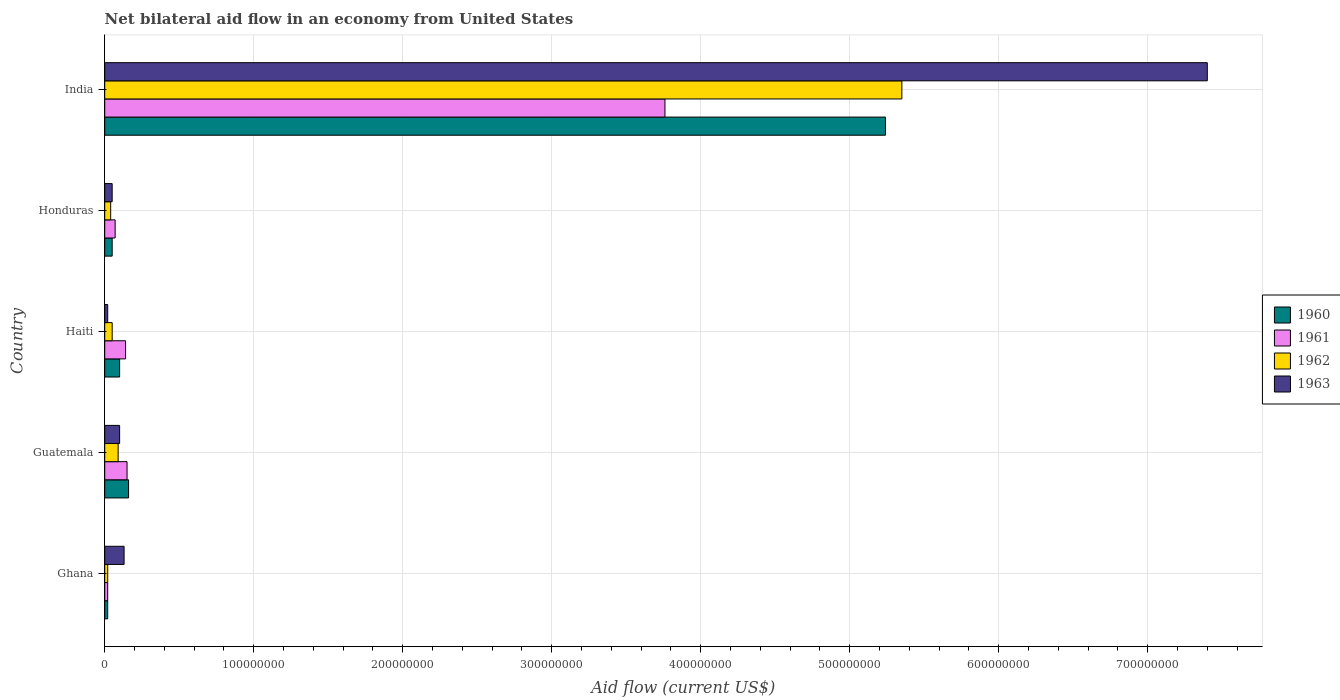How many different coloured bars are there?
Provide a short and direct response. 4. How many groups of bars are there?
Your answer should be compact. 5. How many bars are there on the 4th tick from the bottom?
Ensure brevity in your answer.  4. What is the label of the 4th group of bars from the top?
Ensure brevity in your answer.  Guatemala. What is the net bilateral aid flow in 1962 in Guatemala?
Keep it short and to the point. 9.00e+06. Across all countries, what is the maximum net bilateral aid flow in 1963?
Ensure brevity in your answer.  7.40e+08. Across all countries, what is the minimum net bilateral aid flow in 1961?
Make the answer very short. 2.00e+06. In which country was the net bilateral aid flow in 1963 maximum?
Offer a very short reply. India. In which country was the net bilateral aid flow in 1963 minimum?
Provide a succinct answer. Haiti. What is the total net bilateral aid flow in 1960 in the graph?
Ensure brevity in your answer.  5.57e+08. What is the difference between the net bilateral aid flow in 1960 in Guatemala and that in Honduras?
Make the answer very short. 1.10e+07. What is the difference between the net bilateral aid flow in 1960 in Haiti and the net bilateral aid flow in 1962 in Honduras?
Your answer should be compact. 6.00e+06. What is the average net bilateral aid flow in 1961 per country?
Offer a terse response. 8.28e+07. What is the difference between the net bilateral aid flow in 1960 and net bilateral aid flow in 1962 in Haiti?
Your response must be concise. 5.00e+06. What is the difference between the highest and the second highest net bilateral aid flow in 1961?
Make the answer very short. 3.61e+08. What is the difference between the highest and the lowest net bilateral aid flow in 1960?
Make the answer very short. 5.22e+08. In how many countries, is the net bilateral aid flow in 1962 greater than the average net bilateral aid flow in 1962 taken over all countries?
Provide a succinct answer. 1. What does the 2nd bar from the bottom in Haiti represents?
Your answer should be compact. 1961. How many bars are there?
Your answer should be compact. 20. Are all the bars in the graph horizontal?
Your answer should be compact. Yes. How many countries are there in the graph?
Provide a succinct answer. 5. Are the values on the major ticks of X-axis written in scientific E-notation?
Your answer should be compact. No. Does the graph contain any zero values?
Offer a very short reply. No. How many legend labels are there?
Your response must be concise. 4. How are the legend labels stacked?
Give a very brief answer. Vertical. What is the title of the graph?
Provide a short and direct response. Net bilateral aid flow in an economy from United States. What is the label or title of the X-axis?
Give a very brief answer. Aid flow (current US$). What is the Aid flow (current US$) in 1960 in Ghana?
Give a very brief answer. 2.00e+06. What is the Aid flow (current US$) of 1963 in Ghana?
Offer a very short reply. 1.30e+07. What is the Aid flow (current US$) of 1960 in Guatemala?
Provide a succinct answer. 1.60e+07. What is the Aid flow (current US$) of 1961 in Guatemala?
Ensure brevity in your answer.  1.50e+07. What is the Aid flow (current US$) in 1962 in Guatemala?
Give a very brief answer. 9.00e+06. What is the Aid flow (current US$) in 1961 in Haiti?
Offer a very short reply. 1.40e+07. What is the Aid flow (current US$) of 1963 in Haiti?
Offer a very short reply. 2.00e+06. What is the Aid flow (current US$) of 1961 in Honduras?
Provide a succinct answer. 7.00e+06. What is the Aid flow (current US$) in 1962 in Honduras?
Ensure brevity in your answer.  4.00e+06. What is the Aid flow (current US$) of 1963 in Honduras?
Ensure brevity in your answer.  5.00e+06. What is the Aid flow (current US$) in 1960 in India?
Offer a very short reply. 5.24e+08. What is the Aid flow (current US$) in 1961 in India?
Give a very brief answer. 3.76e+08. What is the Aid flow (current US$) in 1962 in India?
Make the answer very short. 5.35e+08. What is the Aid flow (current US$) of 1963 in India?
Your answer should be compact. 7.40e+08. Across all countries, what is the maximum Aid flow (current US$) in 1960?
Offer a very short reply. 5.24e+08. Across all countries, what is the maximum Aid flow (current US$) in 1961?
Ensure brevity in your answer.  3.76e+08. Across all countries, what is the maximum Aid flow (current US$) of 1962?
Give a very brief answer. 5.35e+08. Across all countries, what is the maximum Aid flow (current US$) of 1963?
Provide a succinct answer. 7.40e+08. Across all countries, what is the minimum Aid flow (current US$) of 1961?
Provide a succinct answer. 2.00e+06. Across all countries, what is the minimum Aid flow (current US$) of 1962?
Your answer should be very brief. 2.00e+06. What is the total Aid flow (current US$) of 1960 in the graph?
Your answer should be compact. 5.57e+08. What is the total Aid flow (current US$) in 1961 in the graph?
Keep it short and to the point. 4.14e+08. What is the total Aid flow (current US$) of 1962 in the graph?
Your response must be concise. 5.55e+08. What is the total Aid flow (current US$) of 1963 in the graph?
Provide a succinct answer. 7.70e+08. What is the difference between the Aid flow (current US$) of 1960 in Ghana and that in Guatemala?
Offer a very short reply. -1.40e+07. What is the difference between the Aid flow (current US$) of 1961 in Ghana and that in Guatemala?
Give a very brief answer. -1.30e+07. What is the difference between the Aid flow (current US$) of 1962 in Ghana and that in Guatemala?
Offer a very short reply. -7.00e+06. What is the difference between the Aid flow (current US$) of 1960 in Ghana and that in Haiti?
Provide a short and direct response. -8.00e+06. What is the difference between the Aid flow (current US$) in 1961 in Ghana and that in Haiti?
Offer a terse response. -1.20e+07. What is the difference between the Aid flow (current US$) of 1963 in Ghana and that in Haiti?
Provide a short and direct response. 1.10e+07. What is the difference between the Aid flow (current US$) of 1961 in Ghana and that in Honduras?
Your answer should be very brief. -5.00e+06. What is the difference between the Aid flow (current US$) in 1960 in Ghana and that in India?
Your answer should be very brief. -5.22e+08. What is the difference between the Aid flow (current US$) in 1961 in Ghana and that in India?
Provide a succinct answer. -3.74e+08. What is the difference between the Aid flow (current US$) of 1962 in Ghana and that in India?
Your answer should be very brief. -5.33e+08. What is the difference between the Aid flow (current US$) in 1963 in Ghana and that in India?
Your response must be concise. -7.27e+08. What is the difference between the Aid flow (current US$) in 1960 in Guatemala and that in Honduras?
Ensure brevity in your answer.  1.10e+07. What is the difference between the Aid flow (current US$) of 1961 in Guatemala and that in Honduras?
Ensure brevity in your answer.  8.00e+06. What is the difference between the Aid flow (current US$) in 1962 in Guatemala and that in Honduras?
Give a very brief answer. 5.00e+06. What is the difference between the Aid flow (current US$) in 1963 in Guatemala and that in Honduras?
Ensure brevity in your answer.  5.00e+06. What is the difference between the Aid flow (current US$) in 1960 in Guatemala and that in India?
Offer a terse response. -5.08e+08. What is the difference between the Aid flow (current US$) in 1961 in Guatemala and that in India?
Offer a terse response. -3.61e+08. What is the difference between the Aid flow (current US$) in 1962 in Guatemala and that in India?
Offer a terse response. -5.26e+08. What is the difference between the Aid flow (current US$) of 1963 in Guatemala and that in India?
Provide a short and direct response. -7.30e+08. What is the difference between the Aid flow (current US$) of 1961 in Haiti and that in Honduras?
Provide a short and direct response. 7.00e+06. What is the difference between the Aid flow (current US$) in 1962 in Haiti and that in Honduras?
Your answer should be very brief. 1.00e+06. What is the difference between the Aid flow (current US$) in 1963 in Haiti and that in Honduras?
Make the answer very short. -3.00e+06. What is the difference between the Aid flow (current US$) of 1960 in Haiti and that in India?
Give a very brief answer. -5.14e+08. What is the difference between the Aid flow (current US$) in 1961 in Haiti and that in India?
Make the answer very short. -3.62e+08. What is the difference between the Aid flow (current US$) of 1962 in Haiti and that in India?
Offer a terse response. -5.30e+08. What is the difference between the Aid flow (current US$) in 1963 in Haiti and that in India?
Provide a succinct answer. -7.38e+08. What is the difference between the Aid flow (current US$) in 1960 in Honduras and that in India?
Provide a succinct answer. -5.19e+08. What is the difference between the Aid flow (current US$) in 1961 in Honduras and that in India?
Provide a succinct answer. -3.69e+08. What is the difference between the Aid flow (current US$) of 1962 in Honduras and that in India?
Ensure brevity in your answer.  -5.31e+08. What is the difference between the Aid flow (current US$) in 1963 in Honduras and that in India?
Your answer should be compact. -7.35e+08. What is the difference between the Aid flow (current US$) in 1960 in Ghana and the Aid flow (current US$) in 1961 in Guatemala?
Provide a short and direct response. -1.30e+07. What is the difference between the Aid flow (current US$) in 1960 in Ghana and the Aid flow (current US$) in 1962 in Guatemala?
Offer a very short reply. -7.00e+06. What is the difference between the Aid flow (current US$) of 1960 in Ghana and the Aid flow (current US$) of 1963 in Guatemala?
Your answer should be very brief. -8.00e+06. What is the difference between the Aid flow (current US$) in 1961 in Ghana and the Aid flow (current US$) in 1962 in Guatemala?
Offer a very short reply. -7.00e+06. What is the difference between the Aid flow (current US$) of 1961 in Ghana and the Aid flow (current US$) of 1963 in Guatemala?
Ensure brevity in your answer.  -8.00e+06. What is the difference between the Aid flow (current US$) in 1962 in Ghana and the Aid flow (current US$) in 1963 in Guatemala?
Keep it short and to the point. -8.00e+06. What is the difference between the Aid flow (current US$) of 1960 in Ghana and the Aid flow (current US$) of 1961 in Haiti?
Provide a succinct answer. -1.20e+07. What is the difference between the Aid flow (current US$) of 1961 in Ghana and the Aid flow (current US$) of 1963 in Haiti?
Provide a short and direct response. 0. What is the difference between the Aid flow (current US$) of 1962 in Ghana and the Aid flow (current US$) of 1963 in Haiti?
Keep it short and to the point. 0. What is the difference between the Aid flow (current US$) in 1960 in Ghana and the Aid flow (current US$) in 1961 in Honduras?
Keep it short and to the point. -5.00e+06. What is the difference between the Aid flow (current US$) in 1960 in Ghana and the Aid flow (current US$) in 1962 in Honduras?
Your answer should be very brief. -2.00e+06. What is the difference between the Aid flow (current US$) in 1960 in Ghana and the Aid flow (current US$) in 1963 in Honduras?
Offer a terse response. -3.00e+06. What is the difference between the Aid flow (current US$) of 1961 in Ghana and the Aid flow (current US$) of 1962 in Honduras?
Keep it short and to the point. -2.00e+06. What is the difference between the Aid flow (current US$) in 1961 in Ghana and the Aid flow (current US$) in 1963 in Honduras?
Give a very brief answer. -3.00e+06. What is the difference between the Aid flow (current US$) in 1960 in Ghana and the Aid flow (current US$) in 1961 in India?
Give a very brief answer. -3.74e+08. What is the difference between the Aid flow (current US$) of 1960 in Ghana and the Aid flow (current US$) of 1962 in India?
Your answer should be compact. -5.33e+08. What is the difference between the Aid flow (current US$) in 1960 in Ghana and the Aid flow (current US$) in 1963 in India?
Give a very brief answer. -7.38e+08. What is the difference between the Aid flow (current US$) in 1961 in Ghana and the Aid flow (current US$) in 1962 in India?
Your answer should be very brief. -5.33e+08. What is the difference between the Aid flow (current US$) of 1961 in Ghana and the Aid flow (current US$) of 1963 in India?
Provide a succinct answer. -7.38e+08. What is the difference between the Aid flow (current US$) of 1962 in Ghana and the Aid flow (current US$) of 1963 in India?
Offer a terse response. -7.38e+08. What is the difference between the Aid flow (current US$) of 1960 in Guatemala and the Aid flow (current US$) of 1962 in Haiti?
Provide a short and direct response. 1.10e+07. What is the difference between the Aid flow (current US$) of 1960 in Guatemala and the Aid flow (current US$) of 1963 in Haiti?
Keep it short and to the point. 1.40e+07. What is the difference between the Aid flow (current US$) of 1961 in Guatemala and the Aid flow (current US$) of 1963 in Haiti?
Offer a terse response. 1.30e+07. What is the difference between the Aid flow (current US$) of 1962 in Guatemala and the Aid flow (current US$) of 1963 in Haiti?
Ensure brevity in your answer.  7.00e+06. What is the difference between the Aid flow (current US$) of 1960 in Guatemala and the Aid flow (current US$) of 1961 in Honduras?
Your answer should be compact. 9.00e+06. What is the difference between the Aid flow (current US$) of 1960 in Guatemala and the Aid flow (current US$) of 1962 in Honduras?
Keep it short and to the point. 1.20e+07. What is the difference between the Aid flow (current US$) in 1960 in Guatemala and the Aid flow (current US$) in 1963 in Honduras?
Provide a short and direct response. 1.10e+07. What is the difference between the Aid flow (current US$) of 1961 in Guatemala and the Aid flow (current US$) of 1962 in Honduras?
Give a very brief answer. 1.10e+07. What is the difference between the Aid flow (current US$) in 1962 in Guatemala and the Aid flow (current US$) in 1963 in Honduras?
Provide a short and direct response. 4.00e+06. What is the difference between the Aid flow (current US$) in 1960 in Guatemala and the Aid flow (current US$) in 1961 in India?
Ensure brevity in your answer.  -3.60e+08. What is the difference between the Aid flow (current US$) in 1960 in Guatemala and the Aid flow (current US$) in 1962 in India?
Keep it short and to the point. -5.19e+08. What is the difference between the Aid flow (current US$) in 1960 in Guatemala and the Aid flow (current US$) in 1963 in India?
Ensure brevity in your answer.  -7.24e+08. What is the difference between the Aid flow (current US$) in 1961 in Guatemala and the Aid flow (current US$) in 1962 in India?
Your answer should be compact. -5.20e+08. What is the difference between the Aid flow (current US$) in 1961 in Guatemala and the Aid flow (current US$) in 1963 in India?
Your answer should be very brief. -7.25e+08. What is the difference between the Aid flow (current US$) in 1962 in Guatemala and the Aid flow (current US$) in 1963 in India?
Ensure brevity in your answer.  -7.31e+08. What is the difference between the Aid flow (current US$) in 1961 in Haiti and the Aid flow (current US$) in 1963 in Honduras?
Provide a succinct answer. 9.00e+06. What is the difference between the Aid flow (current US$) of 1960 in Haiti and the Aid flow (current US$) of 1961 in India?
Ensure brevity in your answer.  -3.66e+08. What is the difference between the Aid flow (current US$) of 1960 in Haiti and the Aid flow (current US$) of 1962 in India?
Offer a terse response. -5.25e+08. What is the difference between the Aid flow (current US$) of 1960 in Haiti and the Aid flow (current US$) of 1963 in India?
Offer a terse response. -7.30e+08. What is the difference between the Aid flow (current US$) of 1961 in Haiti and the Aid flow (current US$) of 1962 in India?
Keep it short and to the point. -5.21e+08. What is the difference between the Aid flow (current US$) of 1961 in Haiti and the Aid flow (current US$) of 1963 in India?
Your response must be concise. -7.26e+08. What is the difference between the Aid flow (current US$) of 1962 in Haiti and the Aid flow (current US$) of 1963 in India?
Your response must be concise. -7.35e+08. What is the difference between the Aid flow (current US$) in 1960 in Honduras and the Aid flow (current US$) in 1961 in India?
Make the answer very short. -3.71e+08. What is the difference between the Aid flow (current US$) in 1960 in Honduras and the Aid flow (current US$) in 1962 in India?
Offer a very short reply. -5.30e+08. What is the difference between the Aid flow (current US$) in 1960 in Honduras and the Aid flow (current US$) in 1963 in India?
Offer a terse response. -7.35e+08. What is the difference between the Aid flow (current US$) in 1961 in Honduras and the Aid flow (current US$) in 1962 in India?
Your answer should be very brief. -5.28e+08. What is the difference between the Aid flow (current US$) of 1961 in Honduras and the Aid flow (current US$) of 1963 in India?
Your answer should be compact. -7.33e+08. What is the difference between the Aid flow (current US$) in 1962 in Honduras and the Aid flow (current US$) in 1963 in India?
Make the answer very short. -7.36e+08. What is the average Aid flow (current US$) in 1960 per country?
Provide a short and direct response. 1.11e+08. What is the average Aid flow (current US$) of 1961 per country?
Offer a terse response. 8.28e+07. What is the average Aid flow (current US$) of 1962 per country?
Ensure brevity in your answer.  1.11e+08. What is the average Aid flow (current US$) in 1963 per country?
Your response must be concise. 1.54e+08. What is the difference between the Aid flow (current US$) in 1960 and Aid flow (current US$) in 1961 in Ghana?
Give a very brief answer. 0. What is the difference between the Aid flow (current US$) in 1960 and Aid flow (current US$) in 1963 in Ghana?
Offer a very short reply. -1.10e+07. What is the difference between the Aid flow (current US$) of 1961 and Aid flow (current US$) of 1962 in Ghana?
Give a very brief answer. 0. What is the difference between the Aid flow (current US$) of 1961 and Aid flow (current US$) of 1963 in Ghana?
Offer a very short reply. -1.10e+07. What is the difference between the Aid flow (current US$) of 1962 and Aid flow (current US$) of 1963 in Ghana?
Offer a very short reply. -1.10e+07. What is the difference between the Aid flow (current US$) of 1960 and Aid flow (current US$) of 1962 in Guatemala?
Keep it short and to the point. 7.00e+06. What is the difference between the Aid flow (current US$) of 1962 and Aid flow (current US$) of 1963 in Guatemala?
Give a very brief answer. -1.00e+06. What is the difference between the Aid flow (current US$) of 1960 and Aid flow (current US$) of 1963 in Haiti?
Make the answer very short. 8.00e+06. What is the difference between the Aid flow (current US$) in 1961 and Aid flow (current US$) in 1962 in Haiti?
Make the answer very short. 9.00e+06. What is the difference between the Aid flow (current US$) of 1961 and Aid flow (current US$) of 1963 in Haiti?
Offer a very short reply. 1.20e+07. What is the difference between the Aid flow (current US$) in 1960 and Aid flow (current US$) in 1962 in Honduras?
Your response must be concise. 1.00e+06. What is the difference between the Aid flow (current US$) in 1960 and Aid flow (current US$) in 1963 in Honduras?
Your answer should be compact. 0. What is the difference between the Aid flow (current US$) in 1961 and Aid flow (current US$) in 1962 in Honduras?
Your answer should be compact. 3.00e+06. What is the difference between the Aid flow (current US$) in 1962 and Aid flow (current US$) in 1963 in Honduras?
Ensure brevity in your answer.  -1.00e+06. What is the difference between the Aid flow (current US$) in 1960 and Aid flow (current US$) in 1961 in India?
Make the answer very short. 1.48e+08. What is the difference between the Aid flow (current US$) in 1960 and Aid flow (current US$) in 1962 in India?
Provide a short and direct response. -1.10e+07. What is the difference between the Aid flow (current US$) in 1960 and Aid flow (current US$) in 1963 in India?
Keep it short and to the point. -2.16e+08. What is the difference between the Aid flow (current US$) in 1961 and Aid flow (current US$) in 1962 in India?
Ensure brevity in your answer.  -1.59e+08. What is the difference between the Aid flow (current US$) of 1961 and Aid flow (current US$) of 1963 in India?
Your answer should be very brief. -3.64e+08. What is the difference between the Aid flow (current US$) in 1962 and Aid flow (current US$) in 1963 in India?
Provide a succinct answer. -2.05e+08. What is the ratio of the Aid flow (current US$) in 1960 in Ghana to that in Guatemala?
Ensure brevity in your answer.  0.12. What is the ratio of the Aid flow (current US$) in 1961 in Ghana to that in Guatemala?
Your answer should be very brief. 0.13. What is the ratio of the Aid flow (current US$) in 1962 in Ghana to that in Guatemala?
Give a very brief answer. 0.22. What is the ratio of the Aid flow (current US$) in 1963 in Ghana to that in Guatemala?
Ensure brevity in your answer.  1.3. What is the ratio of the Aid flow (current US$) of 1960 in Ghana to that in Haiti?
Provide a succinct answer. 0.2. What is the ratio of the Aid flow (current US$) in 1961 in Ghana to that in Haiti?
Make the answer very short. 0.14. What is the ratio of the Aid flow (current US$) in 1962 in Ghana to that in Haiti?
Your response must be concise. 0.4. What is the ratio of the Aid flow (current US$) of 1963 in Ghana to that in Haiti?
Your answer should be compact. 6.5. What is the ratio of the Aid flow (current US$) of 1961 in Ghana to that in Honduras?
Ensure brevity in your answer.  0.29. What is the ratio of the Aid flow (current US$) of 1963 in Ghana to that in Honduras?
Offer a very short reply. 2.6. What is the ratio of the Aid flow (current US$) of 1960 in Ghana to that in India?
Offer a terse response. 0. What is the ratio of the Aid flow (current US$) in 1961 in Ghana to that in India?
Provide a short and direct response. 0.01. What is the ratio of the Aid flow (current US$) in 1962 in Ghana to that in India?
Your answer should be compact. 0. What is the ratio of the Aid flow (current US$) in 1963 in Ghana to that in India?
Give a very brief answer. 0.02. What is the ratio of the Aid flow (current US$) of 1960 in Guatemala to that in Haiti?
Your answer should be compact. 1.6. What is the ratio of the Aid flow (current US$) in 1961 in Guatemala to that in Haiti?
Give a very brief answer. 1.07. What is the ratio of the Aid flow (current US$) in 1962 in Guatemala to that in Haiti?
Provide a short and direct response. 1.8. What is the ratio of the Aid flow (current US$) of 1960 in Guatemala to that in Honduras?
Provide a short and direct response. 3.2. What is the ratio of the Aid flow (current US$) of 1961 in Guatemala to that in Honduras?
Keep it short and to the point. 2.14. What is the ratio of the Aid flow (current US$) of 1962 in Guatemala to that in Honduras?
Your response must be concise. 2.25. What is the ratio of the Aid flow (current US$) of 1960 in Guatemala to that in India?
Offer a very short reply. 0.03. What is the ratio of the Aid flow (current US$) in 1961 in Guatemala to that in India?
Provide a short and direct response. 0.04. What is the ratio of the Aid flow (current US$) of 1962 in Guatemala to that in India?
Make the answer very short. 0.02. What is the ratio of the Aid flow (current US$) in 1963 in Guatemala to that in India?
Your answer should be compact. 0.01. What is the ratio of the Aid flow (current US$) of 1963 in Haiti to that in Honduras?
Ensure brevity in your answer.  0.4. What is the ratio of the Aid flow (current US$) in 1960 in Haiti to that in India?
Offer a terse response. 0.02. What is the ratio of the Aid flow (current US$) of 1961 in Haiti to that in India?
Your response must be concise. 0.04. What is the ratio of the Aid flow (current US$) in 1962 in Haiti to that in India?
Provide a succinct answer. 0.01. What is the ratio of the Aid flow (current US$) of 1963 in Haiti to that in India?
Provide a short and direct response. 0. What is the ratio of the Aid flow (current US$) in 1960 in Honduras to that in India?
Your answer should be compact. 0.01. What is the ratio of the Aid flow (current US$) in 1961 in Honduras to that in India?
Provide a succinct answer. 0.02. What is the ratio of the Aid flow (current US$) in 1962 in Honduras to that in India?
Your answer should be very brief. 0.01. What is the ratio of the Aid flow (current US$) of 1963 in Honduras to that in India?
Your response must be concise. 0.01. What is the difference between the highest and the second highest Aid flow (current US$) in 1960?
Provide a succinct answer. 5.08e+08. What is the difference between the highest and the second highest Aid flow (current US$) of 1961?
Give a very brief answer. 3.61e+08. What is the difference between the highest and the second highest Aid flow (current US$) of 1962?
Your response must be concise. 5.26e+08. What is the difference between the highest and the second highest Aid flow (current US$) of 1963?
Offer a terse response. 7.27e+08. What is the difference between the highest and the lowest Aid flow (current US$) in 1960?
Your response must be concise. 5.22e+08. What is the difference between the highest and the lowest Aid flow (current US$) of 1961?
Provide a succinct answer. 3.74e+08. What is the difference between the highest and the lowest Aid flow (current US$) in 1962?
Give a very brief answer. 5.33e+08. What is the difference between the highest and the lowest Aid flow (current US$) in 1963?
Provide a short and direct response. 7.38e+08. 